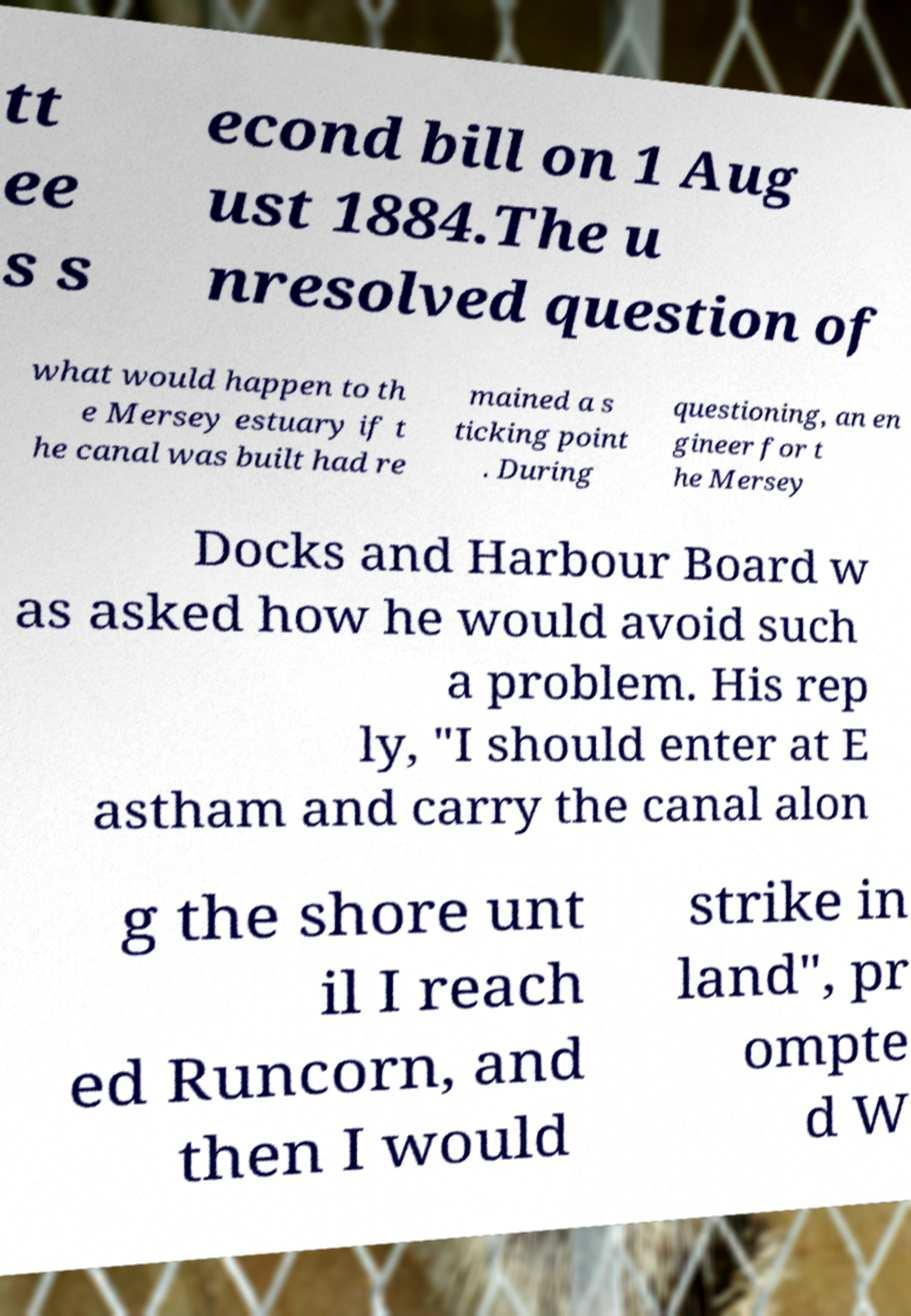I need the written content from this picture converted into text. Can you do that? tt ee s s econd bill on 1 Aug ust 1884.The u nresolved question of what would happen to th e Mersey estuary if t he canal was built had re mained a s ticking point . During questioning, an en gineer for t he Mersey Docks and Harbour Board w as asked how he would avoid such a problem. His rep ly, "I should enter at E astham and carry the canal alon g the shore unt il I reach ed Runcorn, and then I would strike in land", pr ompte d W 